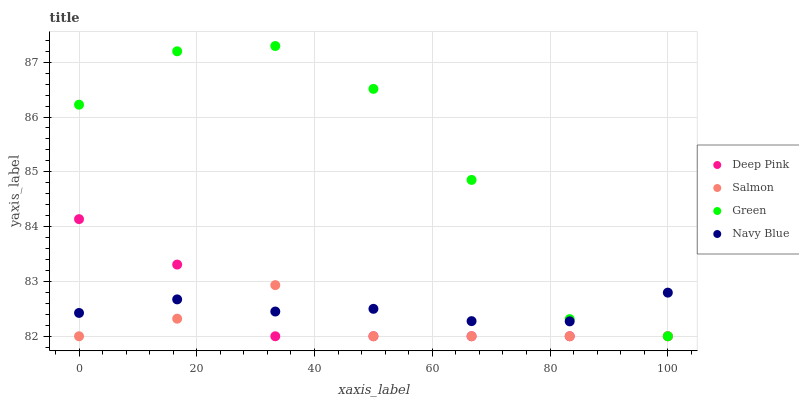Does Salmon have the minimum area under the curve?
Answer yes or no. Yes. Does Green have the maximum area under the curve?
Answer yes or no. Yes. Does Deep Pink have the minimum area under the curve?
Answer yes or no. No. Does Deep Pink have the maximum area under the curve?
Answer yes or no. No. Is Navy Blue the smoothest?
Answer yes or no. Yes. Is Green the roughest?
Answer yes or no. Yes. Is Deep Pink the smoothest?
Answer yes or no. No. Is Deep Pink the roughest?
Answer yes or no. No. Does Green have the lowest value?
Answer yes or no. Yes. Does Navy Blue have the lowest value?
Answer yes or no. No. Does Green have the highest value?
Answer yes or no. Yes. Does Deep Pink have the highest value?
Answer yes or no. No. Does Green intersect Salmon?
Answer yes or no. Yes. Is Green less than Salmon?
Answer yes or no. No. Is Green greater than Salmon?
Answer yes or no. No. 